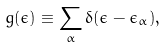<formula> <loc_0><loc_0><loc_500><loc_500>g ( \epsilon ) \equiv \sum _ { \alpha } \delta ( \epsilon - \epsilon _ { \alpha } ) ,</formula> 